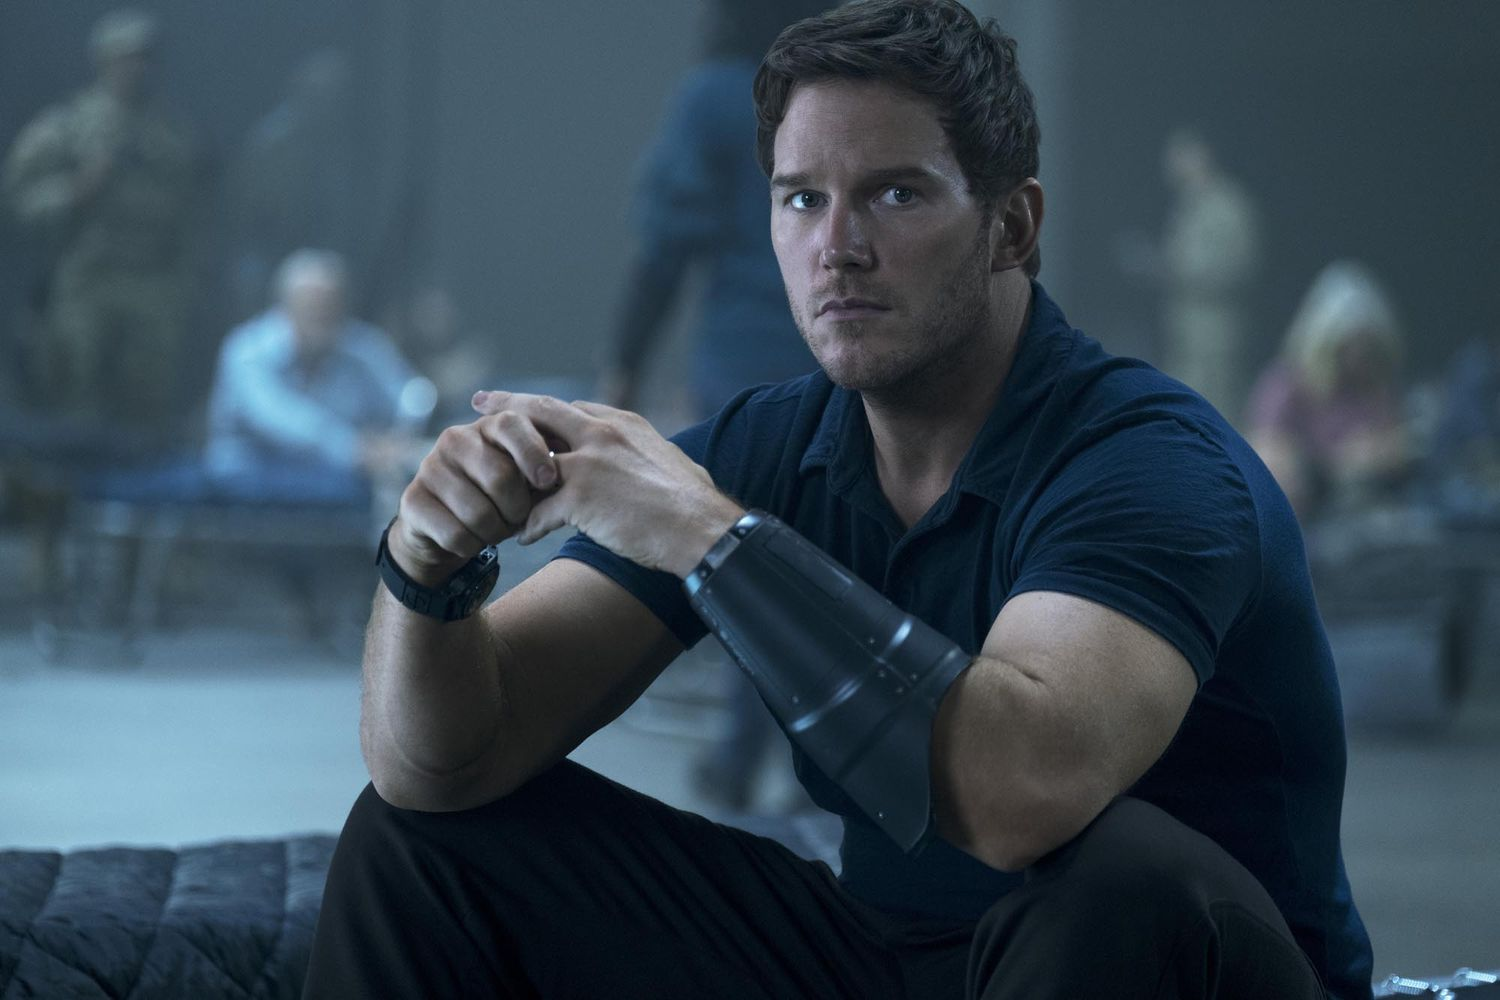Can you describe the emotions conveyed by the individual in the picture? The individual's serious and intent expression, along with their firm posture and tightly clasped hands, suggests emotions of determination or contemplation, possibly indicating their involvement in a critical situation. 